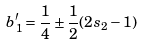Convert formula to latex. <formula><loc_0><loc_0><loc_500><loc_500>b ^ { \prime } _ { 1 } = \frac { 1 } { 4 } \pm \frac { 1 } { 2 } ( 2 s _ { 2 } - 1 )</formula> 